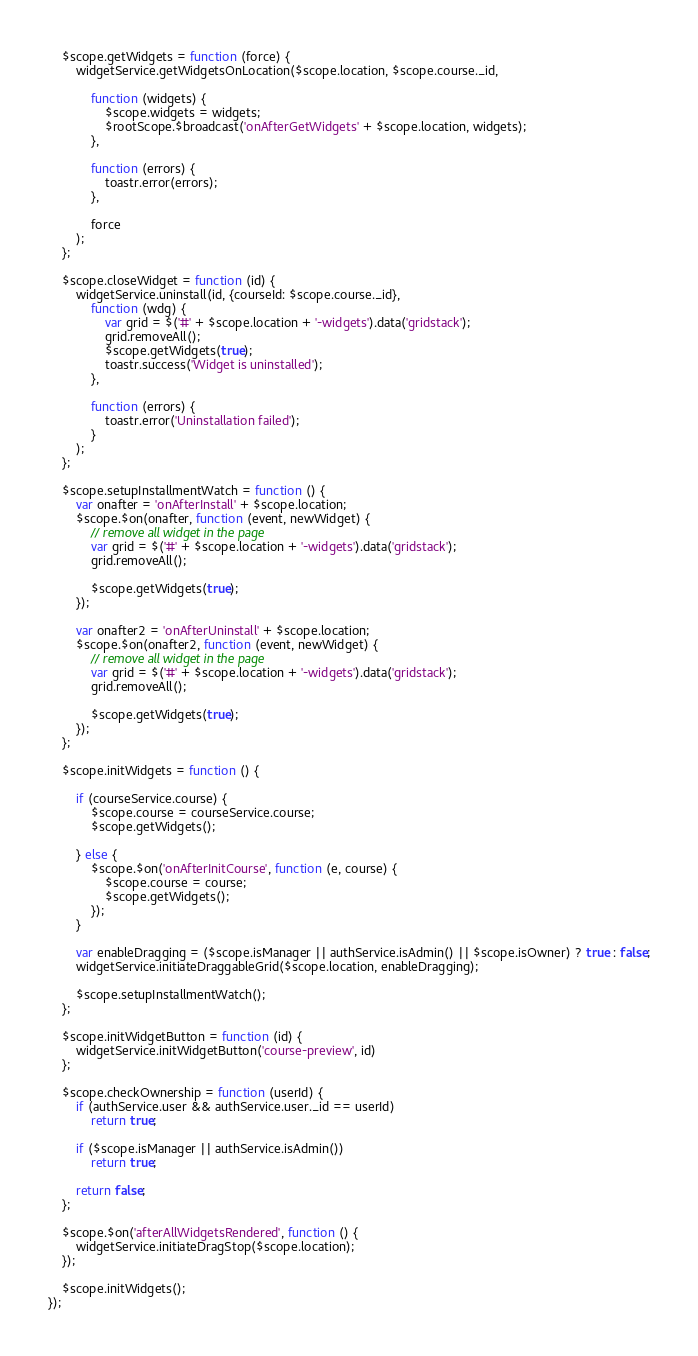<code> <loc_0><loc_0><loc_500><loc_500><_JavaScript_>
    $scope.getWidgets = function (force) {
        widgetService.getWidgetsOnLocation($scope.location, $scope.course._id,

            function (widgets) {
                $scope.widgets = widgets;
                $rootScope.$broadcast('onAfterGetWidgets' + $scope.location, widgets);
            },

            function (errors) {
                toastr.error(errors);
            },

            force
        );
    };

    $scope.closeWidget = function (id) {
        widgetService.uninstall(id, {courseId: $scope.course._id},
            function (wdg) {
                var grid = $('#' + $scope.location + '-widgets').data('gridstack');
                grid.removeAll();
                $scope.getWidgets(true);
                toastr.success('Widget is uninstalled');
            },

            function (errors) {
                toastr.error('Uninstallation failed');
            }
        );
    };

    $scope.setupInstallmentWatch = function () {
        var onafter = 'onAfterInstall' + $scope.location;
        $scope.$on(onafter, function (event, newWidget) {
            // remove all widget in the page
            var grid = $('#' + $scope.location + '-widgets').data('gridstack');
            grid.removeAll();

            $scope.getWidgets(true);
        });

        var onafter2 = 'onAfterUninstall' + $scope.location;
        $scope.$on(onafter2, function (event, newWidget) {
            // remove all widget in the page
            var grid = $('#' + $scope.location + '-widgets').data('gridstack');
            grid.removeAll();

            $scope.getWidgets(true);
        });
    };

    $scope.initWidgets = function () {

        if (courseService.course) {
            $scope.course = courseService.course;
            $scope.getWidgets();

        } else {
            $scope.$on('onAfterInitCourse', function (e, course) {
                $scope.course = course;
                $scope.getWidgets();
            });
        }

        var enableDragging = ($scope.isManager || authService.isAdmin() || $scope.isOwner) ? true : false;
        widgetService.initiateDraggableGrid($scope.location, enableDragging);

        $scope.setupInstallmentWatch();
    };

    $scope.initWidgetButton = function (id) {
        widgetService.initWidgetButton('course-preview', id)
    };

    $scope.checkOwnership = function (userId) {
        if (authService.user && authService.user._id == userId)
            return true;

        if ($scope.isManager || authService.isAdmin())
            return true;

        return false;
    };
 
    $scope.$on('afterAllWidgetsRendered', function () {
        widgetService.initiateDragStop($scope.location);
    });

    $scope.initWidgets();
});
</code> 